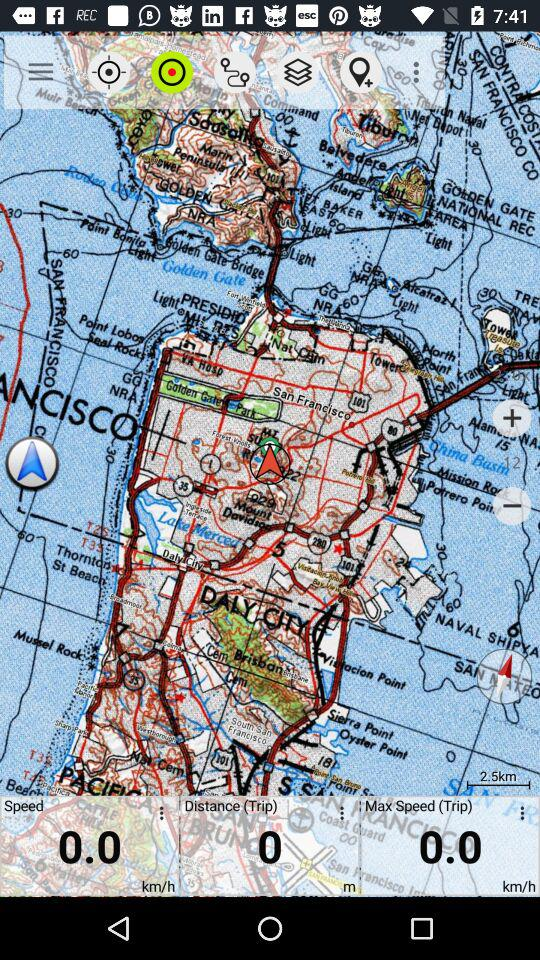How much distance is covered? The covered distance is 0 meters. 